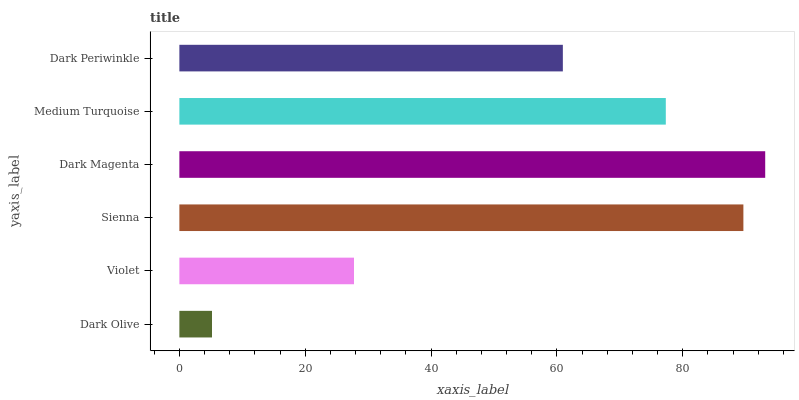Is Dark Olive the minimum?
Answer yes or no. Yes. Is Dark Magenta the maximum?
Answer yes or no. Yes. Is Violet the minimum?
Answer yes or no. No. Is Violet the maximum?
Answer yes or no. No. Is Violet greater than Dark Olive?
Answer yes or no. Yes. Is Dark Olive less than Violet?
Answer yes or no. Yes. Is Dark Olive greater than Violet?
Answer yes or no. No. Is Violet less than Dark Olive?
Answer yes or no. No. Is Medium Turquoise the high median?
Answer yes or no. Yes. Is Dark Periwinkle the low median?
Answer yes or no. Yes. Is Violet the high median?
Answer yes or no. No. Is Medium Turquoise the low median?
Answer yes or no. No. 